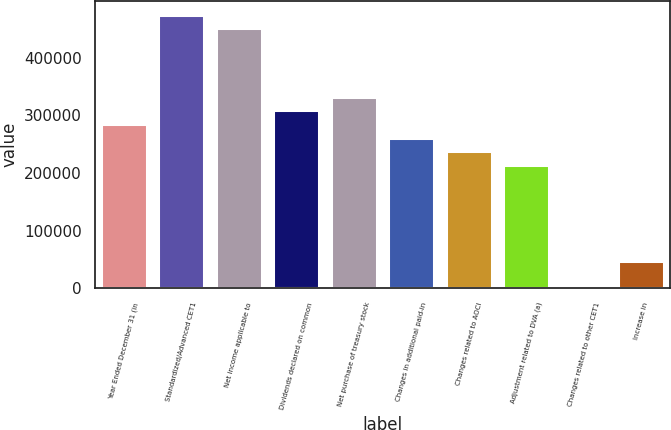<chart> <loc_0><loc_0><loc_500><loc_500><bar_chart><fcel>Year Ended December 31 (in<fcel>Standardized/Advanced CET1<fcel>Net income applicable to<fcel>Dividends declared on common<fcel>Net purchase of treasury stock<fcel>Changes in additional paid-in<fcel>Changes related to AOCI<fcel>Adjustment related to DVA (a)<fcel>Changes related to other CET1<fcel>Increase in<nl><fcel>284972<fcel>474817<fcel>451086<fcel>308703<fcel>332433<fcel>261242<fcel>237511<fcel>213780<fcel>205<fcel>47666.2<nl></chart> 